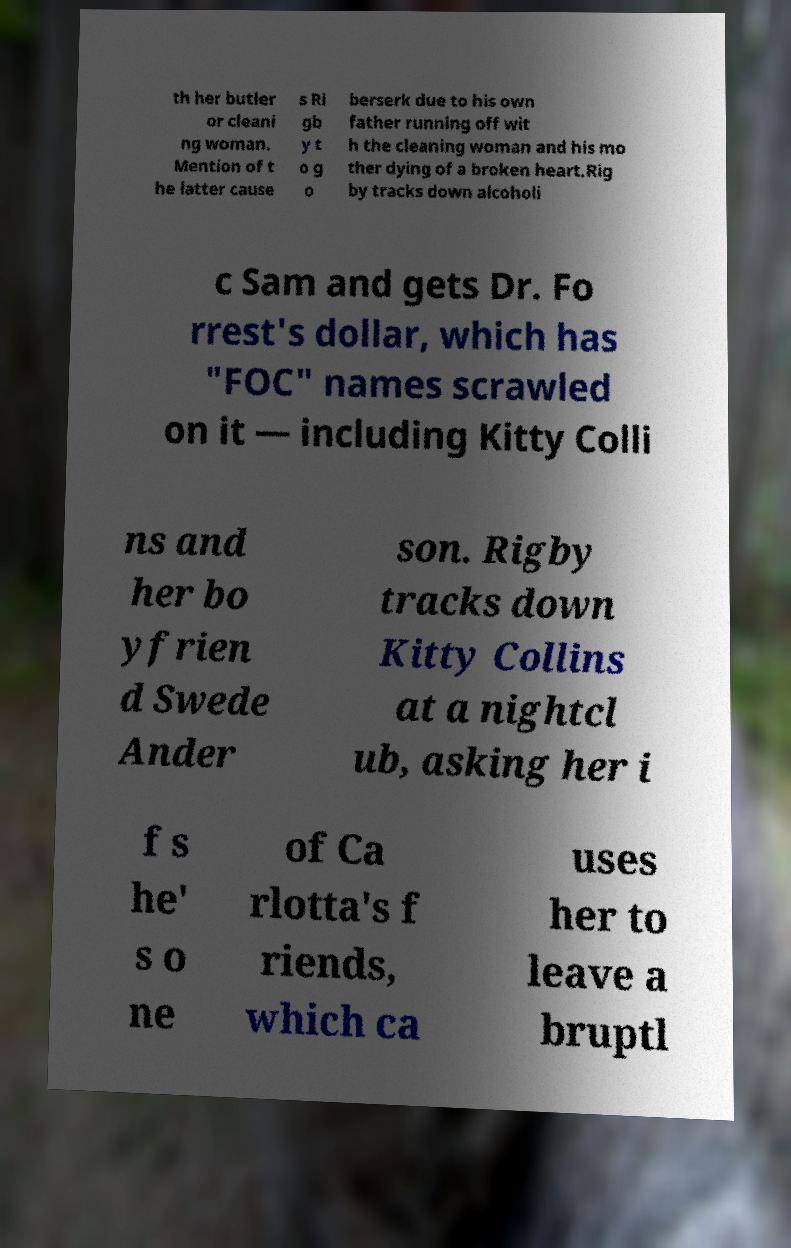Could you assist in decoding the text presented in this image and type it out clearly? th her butler or cleani ng woman. Mention of t he latter cause s Ri gb y t o g o berserk due to his own father running off wit h the cleaning woman and his mo ther dying of a broken heart.Rig by tracks down alcoholi c Sam and gets Dr. Fo rrest's dollar, which has "FOC" names scrawled on it — including Kitty Colli ns and her bo yfrien d Swede Ander son. Rigby tracks down Kitty Collins at a nightcl ub, asking her i f s he' s o ne of Ca rlotta's f riends, which ca uses her to leave a bruptl 